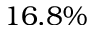Convert formula to latex. <formula><loc_0><loc_0><loc_500><loc_500>1 6 . 8 \%</formula> 